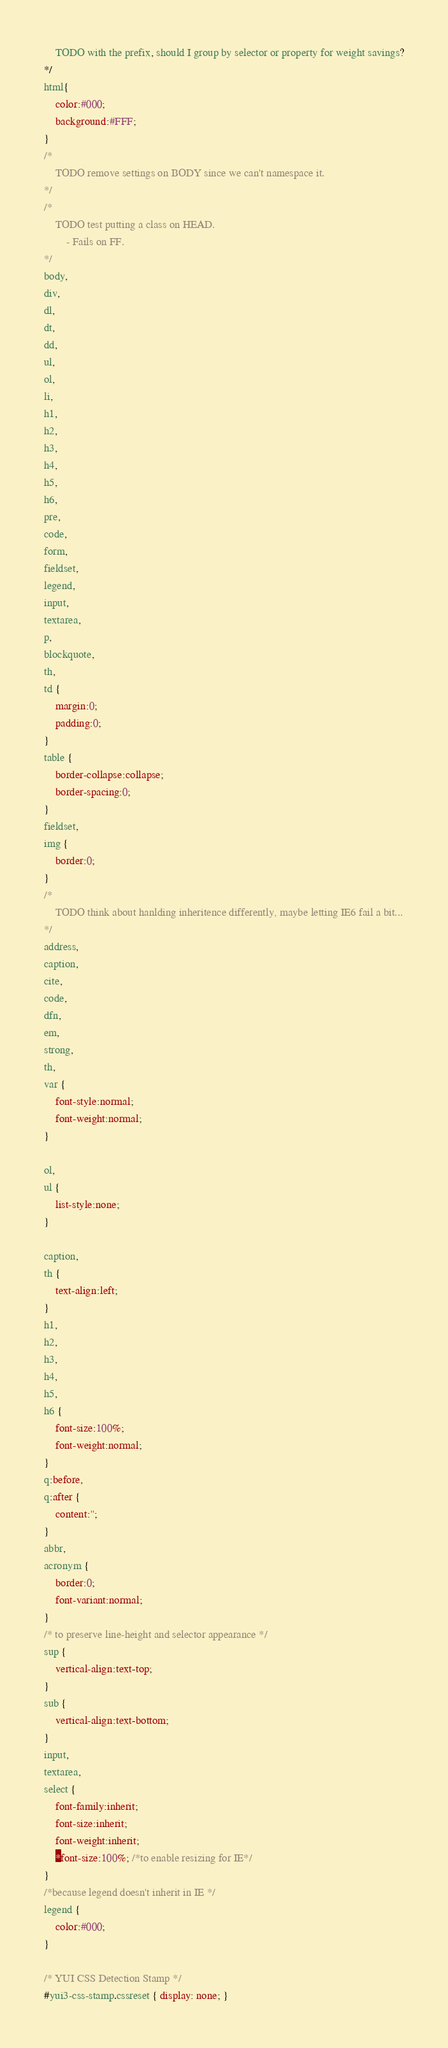Convert code to text. <code><loc_0><loc_0><loc_500><loc_500><_CSS_>	TODO with the prefix, should I group by selector or property for weight savings?
*/
html{
	color:#000;
	background:#FFF;
}
/*
	TODO remove settings on BODY since we can't namespace it.
*/
/*
	TODO test putting a class on HEAD.
		- Fails on FF. 
*/
body,
div,
dl,
dt,
dd,
ul,
ol,
li,
h1,
h2,
h3,
h4,
h5,
h6,
pre,
code,
form,
fieldset,
legend,
input,
textarea,
p,
blockquote,
th,
td {
	margin:0;
	padding:0;
}
table {
	border-collapse:collapse;
	border-spacing:0;
}
fieldset,
img {
	border:0;
}
/*
	TODO think about hanlding inheritence differently, maybe letting IE6 fail a bit...
*/
address,
caption,
cite,
code,
dfn,
em,
strong,
th,
var {
	font-style:normal;
	font-weight:normal;
}

ol,
ul {
	list-style:none;
}

caption,
th {
	text-align:left;
}
h1,
h2,
h3,
h4,
h5,
h6 {
	font-size:100%;
	font-weight:normal;
}
q:before,
q:after {
	content:'';
}
abbr,
acronym {
	border:0;
	font-variant:normal;
}
/* to preserve line-height and selector appearance */
sup {
	vertical-align:text-top;
}
sub {
	vertical-align:text-bottom;
}
input,
textarea,
select {
	font-family:inherit;
	font-size:inherit;
	font-weight:inherit;
	*font-size:100%; /*to enable resizing for IE*/
}
/*because legend doesn't inherit in IE */
legend {
	color:#000;
}

/* YUI CSS Detection Stamp */
#yui3-css-stamp.cssreset { display: none; }
</code> 